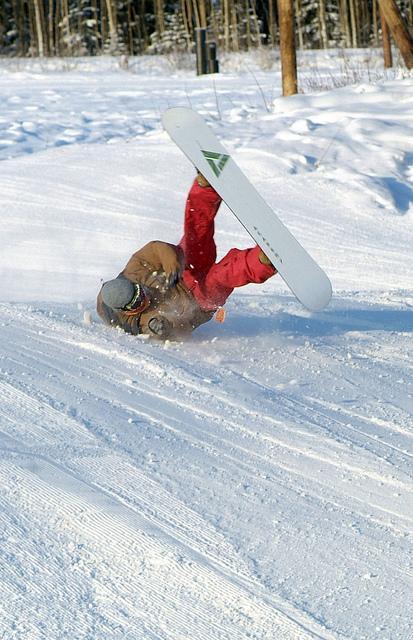How many us airways express airplanes are in this image?
Give a very brief answer. 0. 